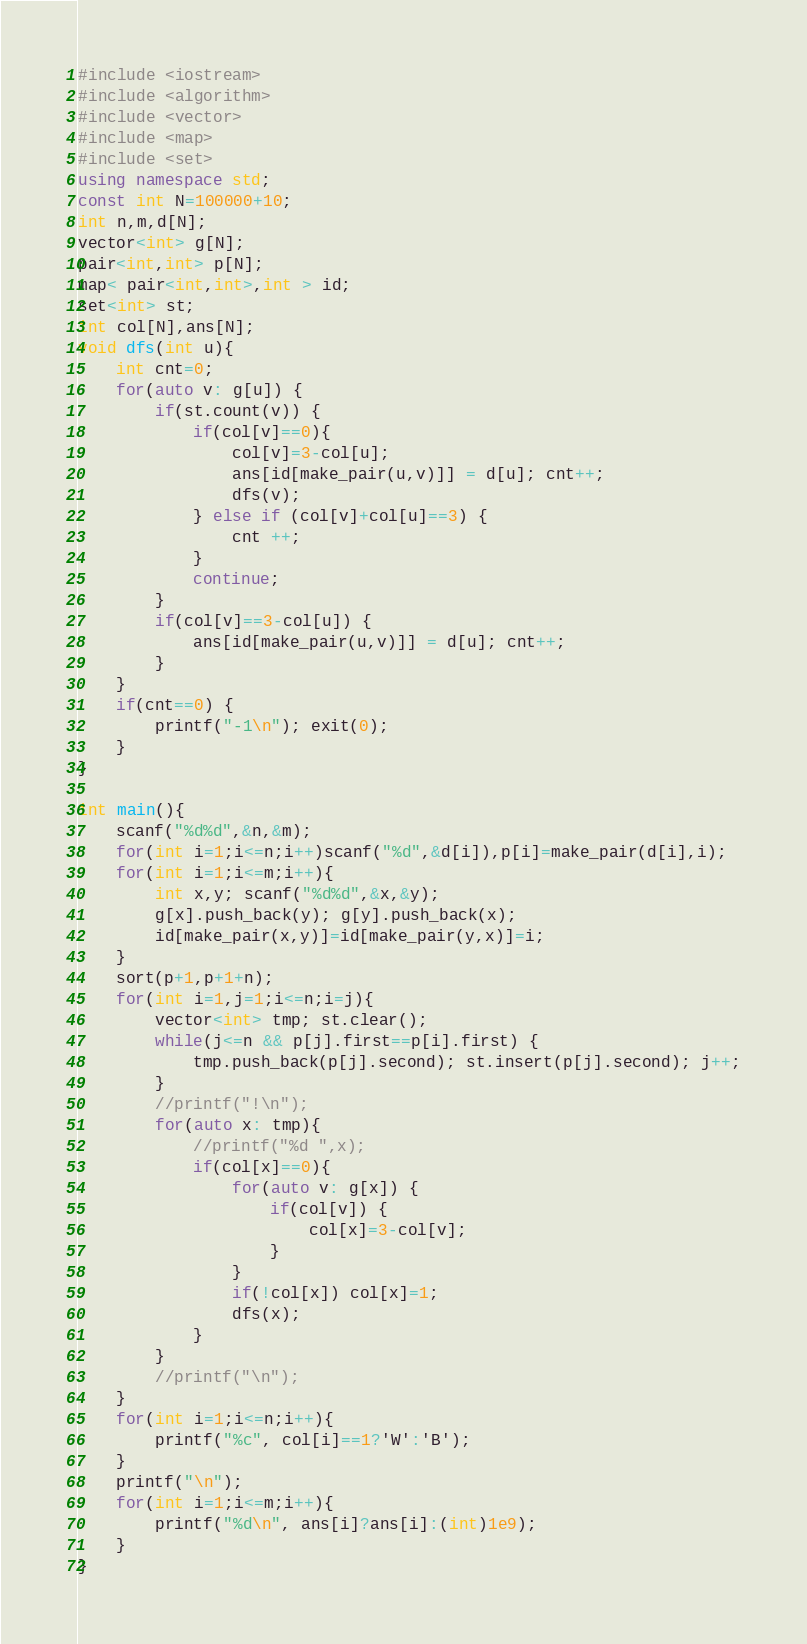Convert code to text. <code><loc_0><loc_0><loc_500><loc_500><_C++_>#include <iostream>
#include <algorithm>
#include <vector>
#include <map>
#include <set>
using namespace std;
const int N=100000+10;
int n,m,d[N];
vector<int> g[N];
pair<int,int> p[N];
map< pair<int,int>,int > id;
set<int> st;
int col[N],ans[N];
void dfs(int u){
    int cnt=0;
    for(auto v: g[u]) {
        if(st.count(v)) {
            if(col[v]==0){
                col[v]=3-col[u]; 
                ans[id[make_pair(u,v)]] = d[u]; cnt++;
                dfs(v);
            } else if (col[v]+col[u]==3) {
                cnt ++;
            }
            continue;
        }
        if(col[v]==3-col[u]) {
            ans[id[make_pair(u,v)]] = d[u]; cnt++;
        }
    }
    if(cnt==0) {
        printf("-1\n"); exit(0);
    }
}

int main(){
    scanf("%d%d",&n,&m);
    for(int i=1;i<=n;i++)scanf("%d",&d[i]),p[i]=make_pair(d[i],i);
    for(int i=1;i<=m;i++){
        int x,y; scanf("%d%d",&x,&y); 
        g[x].push_back(y); g[y].push_back(x);
        id[make_pair(x,y)]=id[make_pair(y,x)]=i;
    }
    sort(p+1,p+1+n);
    for(int i=1,j=1;i<=n;i=j){
        vector<int> tmp; st.clear();
        while(j<=n && p[j].first==p[i].first) {
            tmp.push_back(p[j].second); st.insert(p[j].second); j++;
        }
        //printf("!\n");
        for(auto x: tmp){
            //printf("%d ",x);
            if(col[x]==0){
                for(auto v: g[x]) {
                    if(col[v]) {
                        col[x]=3-col[v];
                    }
                } 
                if(!col[x]) col[x]=1; 
                dfs(x);
            }
        }
        //printf("\n");
    }
    for(int i=1;i<=n;i++){
        printf("%c", col[i]==1?'W':'B');
    }
    printf("\n");
    for(int i=1;i<=m;i++){
        printf("%d\n", ans[i]?ans[i]:(int)1e9);
    }
}</code> 